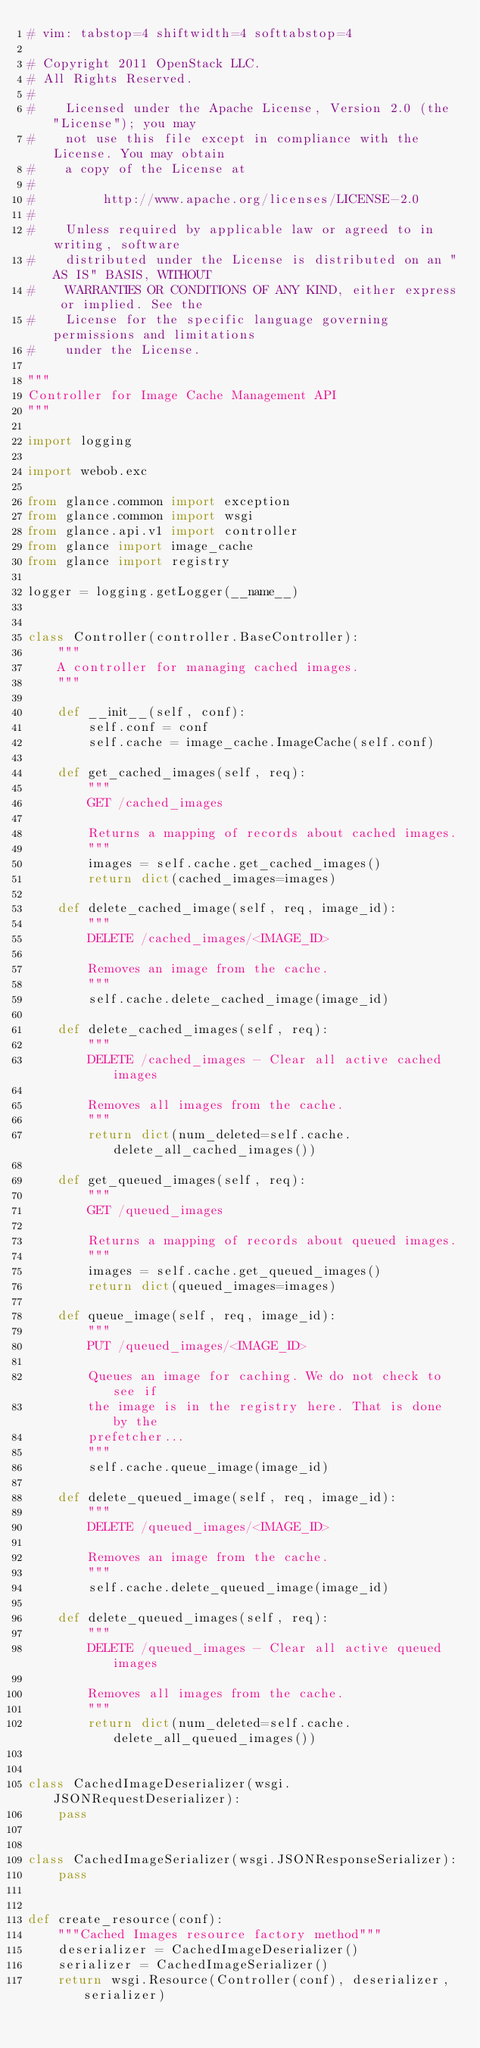<code> <loc_0><loc_0><loc_500><loc_500><_Python_># vim: tabstop=4 shiftwidth=4 softtabstop=4

# Copyright 2011 OpenStack LLC.
# All Rights Reserved.
#
#    Licensed under the Apache License, Version 2.0 (the "License"); you may
#    not use this file except in compliance with the License. You may obtain
#    a copy of the License at
#
#         http://www.apache.org/licenses/LICENSE-2.0
#
#    Unless required by applicable law or agreed to in writing, software
#    distributed under the License is distributed on an "AS IS" BASIS, WITHOUT
#    WARRANTIES OR CONDITIONS OF ANY KIND, either express or implied. See the
#    License for the specific language governing permissions and limitations
#    under the License.

"""
Controller for Image Cache Management API
"""

import logging

import webob.exc

from glance.common import exception
from glance.common import wsgi
from glance.api.v1 import controller
from glance import image_cache
from glance import registry

logger = logging.getLogger(__name__)


class Controller(controller.BaseController):
    """
    A controller for managing cached images.
    """

    def __init__(self, conf):
        self.conf = conf
        self.cache = image_cache.ImageCache(self.conf)

    def get_cached_images(self, req):
        """
        GET /cached_images

        Returns a mapping of records about cached images.
        """
        images = self.cache.get_cached_images()
        return dict(cached_images=images)

    def delete_cached_image(self, req, image_id):
        """
        DELETE /cached_images/<IMAGE_ID>

        Removes an image from the cache.
        """
        self.cache.delete_cached_image(image_id)

    def delete_cached_images(self, req):
        """
        DELETE /cached_images - Clear all active cached images

        Removes all images from the cache.
        """
        return dict(num_deleted=self.cache.delete_all_cached_images())

    def get_queued_images(self, req):
        """
        GET /queued_images

        Returns a mapping of records about queued images.
        """
        images = self.cache.get_queued_images()
        return dict(queued_images=images)

    def queue_image(self, req, image_id):
        """
        PUT /queued_images/<IMAGE_ID>

        Queues an image for caching. We do not check to see if
        the image is in the registry here. That is done by the
        prefetcher...
        """
        self.cache.queue_image(image_id)

    def delete_queued_image(self, req, image_id):
        """
        DELETE /queued_images/<IMAGE_ID>

        Removes an image from the cache.
        """
        self.cache.delete_queued_image(image_id)

    def delete_queued_images(self, req):
        """
        DELETE /queued_images - Clear all active queued images

        Removes all images from the cache.
        """
        return dict(num_deleted=self.cache.delete_all_queued_images())


class CachedImageDeserializer(wsgi.JSONRequestDeserializer):
    pass


class CachedImageSerializer(wsgi.JSONResponseSerializer):
    pass


def create_resource(conf):
    """Cached Images resource factory method"""
    deserializer = CachedImageDeserializer()
    serializer = CachedImageSerializer()
    return wsgi.Resource(Controller(conf), deserializer, serializer)
</code> 